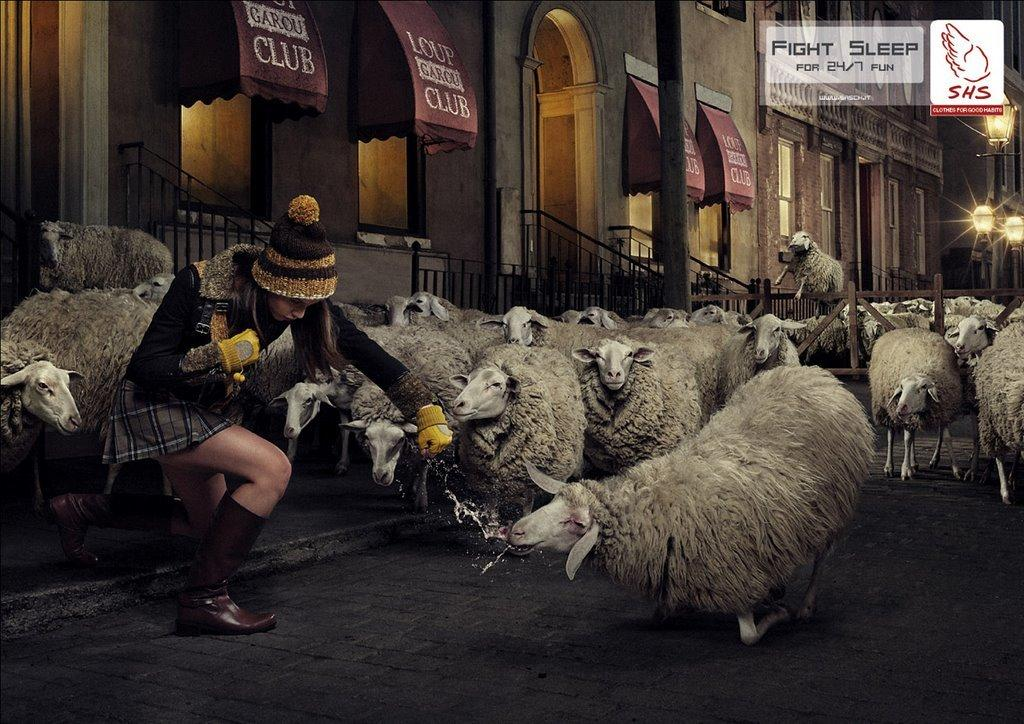Who is on the left side of the image? There is a girl on the left side of the image. What animals are in the middle of the image? There are sheep in the middle of the image. What can be seen in the background of the image? There is a building in the background of the image. Is there a gun visible in the image? No, there is no gun present in the image. What is the impulse of the sheep in the middle of the image? The image does not provide information about the sheep's impulses, as it is a still image. 